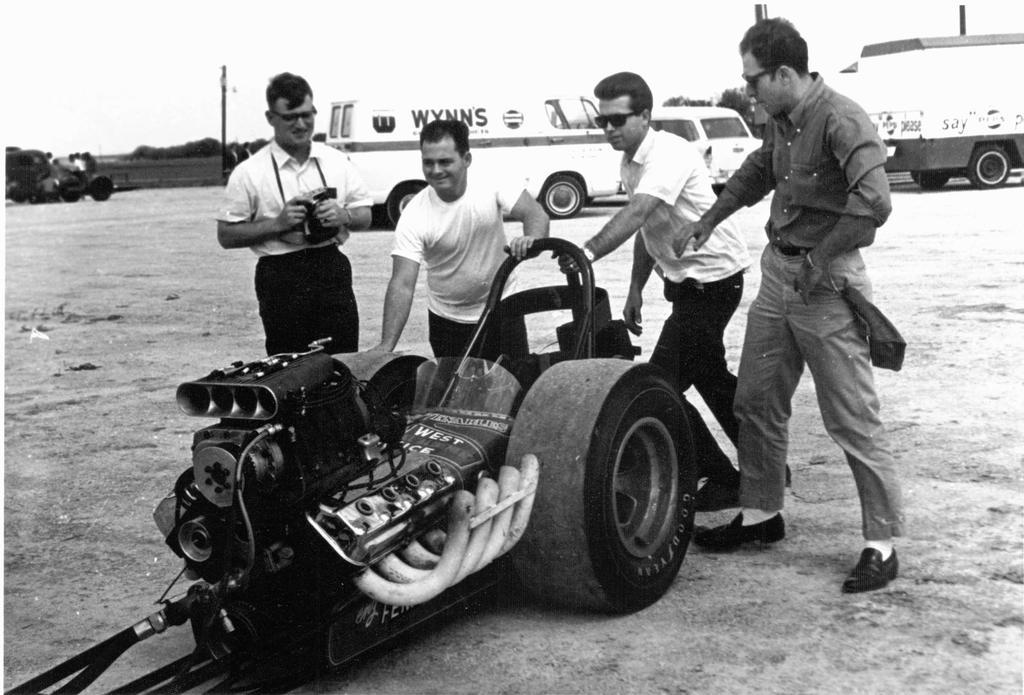Who or what is present in the image? There are people and vehicles in the image. What can be observed about the vehicles in the image? The vehicles are on the ground in the image. How is the image presented in terms of color? The image is in black and white color. What is the cause of the people's laughter in the image? There is no indication of laughter or any specific cause in the image, as it only shows people and vehicles in black and white. 